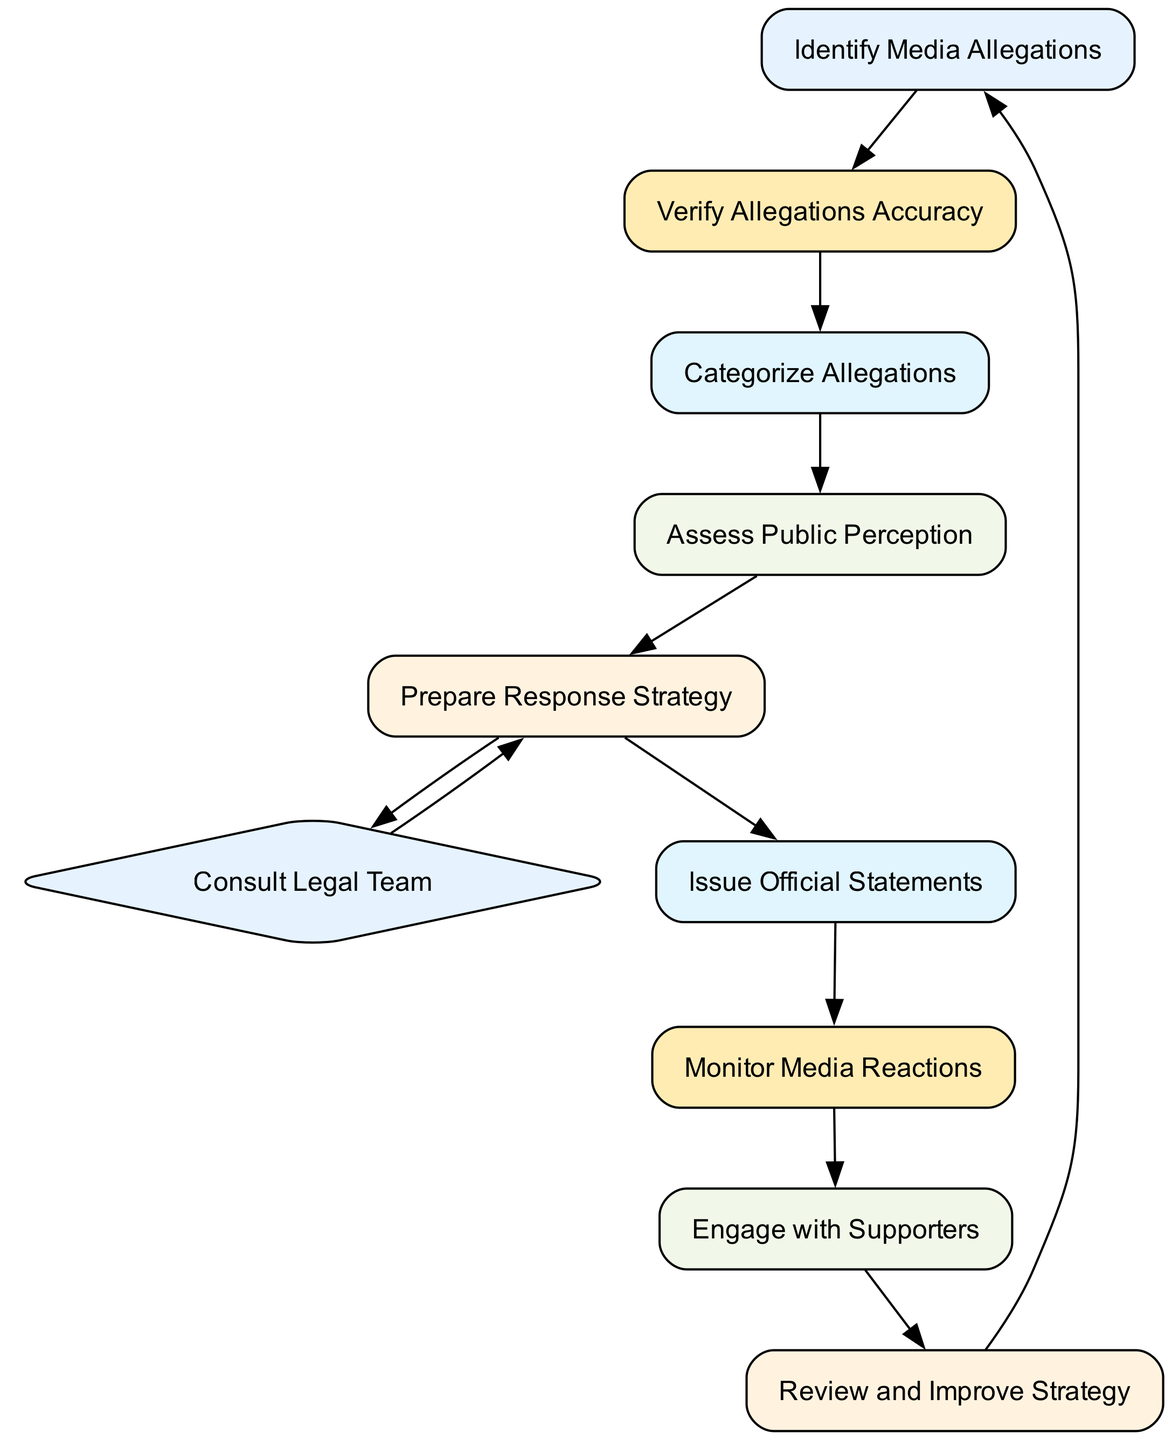What is the first activity in the diagram? The first activity is "Identify Media Allegations," which is identified by its placement as the starting point of the process.
Answer: Identify Media Allegations How many total activities are in the diagram? Counting each unique activity listed in the diagram, there are ten activities in total.
Answer: 10 What follows "Verify Allegations Accuracy"? After "Verify Allegations Accuracy," the next activity is "Categorize Allegations," which is represented by a direct connection from the former to the latter.
Answer: Categorize Allegations What is the purpose of "Engage with Supporters"? "Engage with Supporters" aims to communicate with Boris Johnson's supporters, which is described as a step to maintain trust and support.
Answer: Maintain trust and support In which step do legal consultations occur? Legal consultations occur in the step labeled "Consult Legal Team," which is a branching point in the flow of activities that follows the "Prepare Response Strategy" step.
Answer: Consult Legal Team How do allegations get categorized? Allegations get categorized in the activity "Categorize Allegations," as indicated in the diagram's flow where this activity follows "Verify Allegations Accuracy."
Answer: Categorize Allegations What action is taken after issuing official statements? After issuing official statements, the next action to be taken is to "Monitor Media Reactions," which follows directly after the issuance of these statements.
Answer: Monitor Media Reactions What is the relationship between "Prepare Response Strategy" and "Issue Official Statements"? "Prepare Response Strategy" directly leads to both "Consult Legal Team" and "Issue Official Statements," indicating that both actions can occur simultaneously after forming a response strategy.
Answer: Parallel actions 